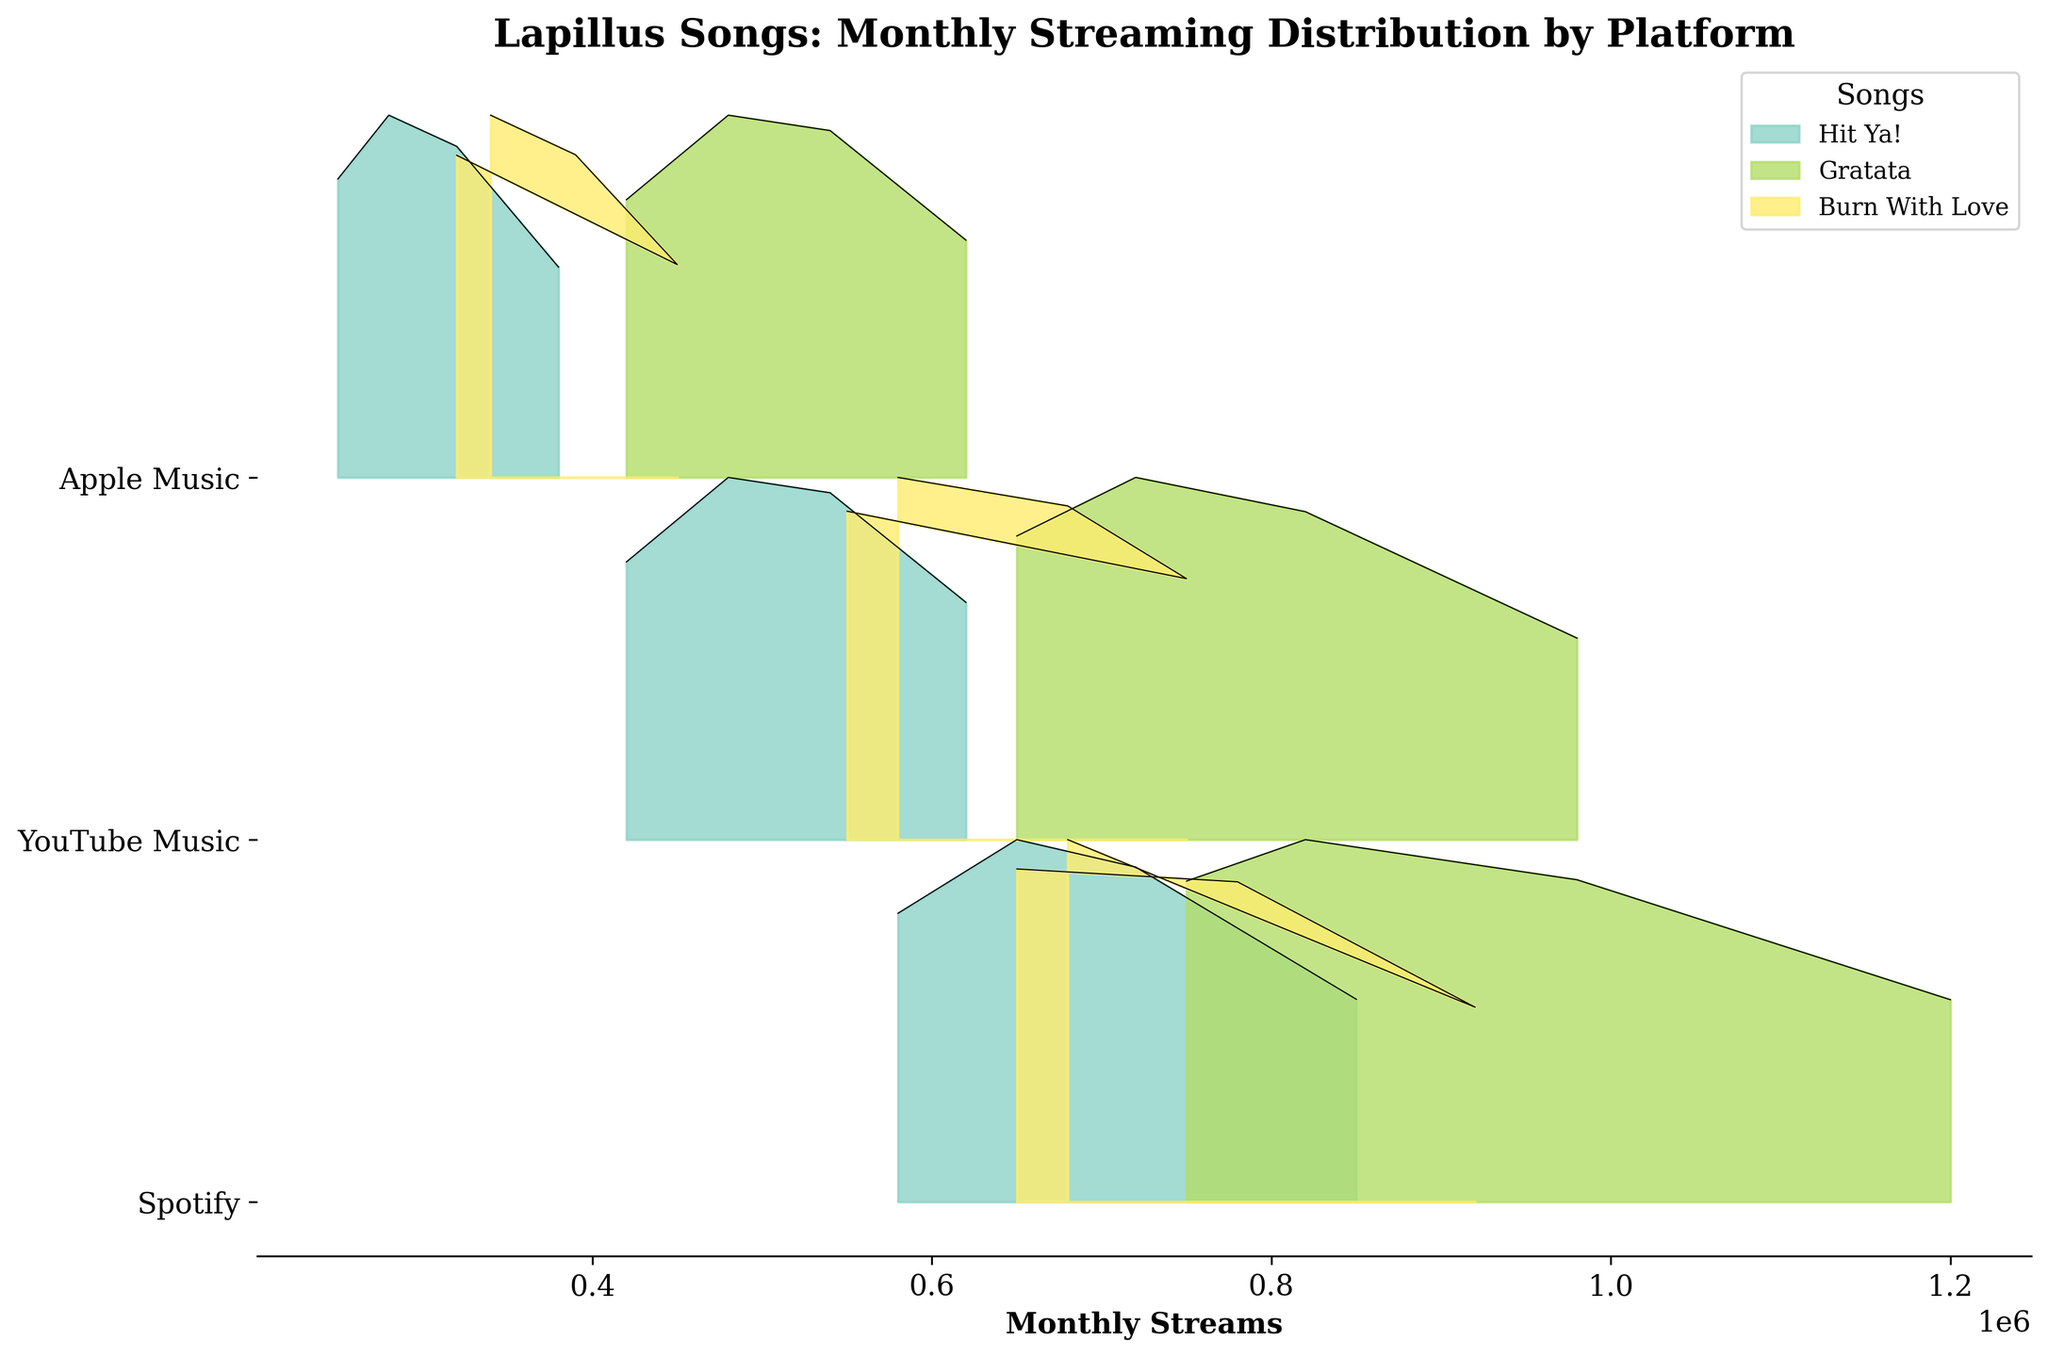Which song has the highest streams on Spotify in January? Look for the peak of each song's distribution on the Spotify line in January and find the highest value. "Gratata" has the highest streams.
Answer: Gratata How do the streaming numbers for "Hit Ya!" vary across different platforms in February? Examine the February streams for "Hit Ya!" across Spotify, YouTube Music, and Apple Music by checking their respective positions on the x-axis. Spotify: 720,000; YouTube Music: 540,000; Apple Music: 320,000
Answer: Spotify: 720,000; YouTube Music: 540,000; Apple Music: 320,000 Which platform has the widest distribution of streams for "Burn With Love" in March? Compare the width of the ridges for "Burn With Love" for each platform in March. Wider distribution indicates a broader range of streams. YouTube Music has the widest distribution.
Answer: YouTube Music What trend can be observed for "Gratata" streams from January to April on Apple Music? Follow the line representing "Gratata" on Apple Music from January to April. The streams decrease steadily over this period.
Answer: Decreasing trend Which song shows an increase in streaming numbers from February to March on Spotify? Check the slope of the lines for each song between February and March on Spotify. "Burn With Love" shows an increase.
Answer: Burn With Love Compare the streaming numbers of "Gratata" and "Hit Ya!" on YouTube Music in April. Which one is higher? Observe the points for "Gratata" and "Hit Ya!" in April on YouTube Music. "Gratata" has higher streaming numbers.
Answer: Gratata On which platform is the difference between the highest and lowest streams for "Hit Ya!" the greatest? Calculate the difference between the highest and lowest points for "Hit Ya!" on each platform. For Spotify (850,000 - 580,000 = 270,000), YouTube Music (620,000 - 420,000 = 200,000), and Apple Music (380,000 - 250,000 = 130,000), the greatest difference is on Spotify.
Answer: Spotify Which song has the most consistent streams across all months on Apple Music? Look at the ridges for each song on Apple Music and determine which one has the least variation. "Burn With Love" appears most consistent.
Answer: Burn With Love Do any songs show a similar pattern of streaming numbers across all three platforms? Compare the overall trends for each song across Spotify, YouTube Music, and Apple Music. "Hit Ya!" shows similar decreasing patterns across all platforms.
Answer: Hit Ya! 